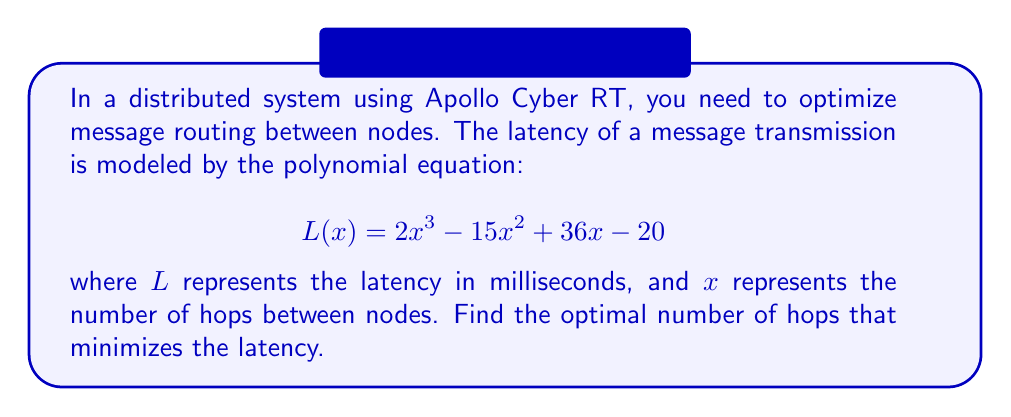What is the answer to this math problem? To find the optimal number of hops that minimizes the latency, we need to find the minimum point of the polynomial function $L(x)$. This can be done by following these steps:

1. Find the derivative of $L(x)$:
   $$L'(x) = 6x^2 - 30x + 36$$

2. Set the derivative equal to zero and solve for x:
   $$6x^2 - 30x + 36 = 0$$

3. Factor the quadratic equation:
   $$6(x^2 - 5x + 6) = 0$$
   $$6(x - 2)(x - 3) = 0$$

4. Solve for x:
   $x = 2$ or $x = 3$

5. To determine which value of x gives the minimum latency, we can either:
   a) Calculate the second derivative and check its sign at x = 2 and x = 3, or
   b) Evaluate L(x) at both points and compare.

   Let's use method b:
   
   $L(2) = 2(2)^3 - 15(2)^2 + 36(2) - 20 = 16 - 60 + 72 - 20 = 8$ ms
   $L(3) = 2(3)^3 - 15(3)^2 + 36(3) - 20 = 54 - 135 + 108 - 20 = 7$ ms

Therefore, the latency is minimized when x = 3 hops.
Answer: 3 hops 